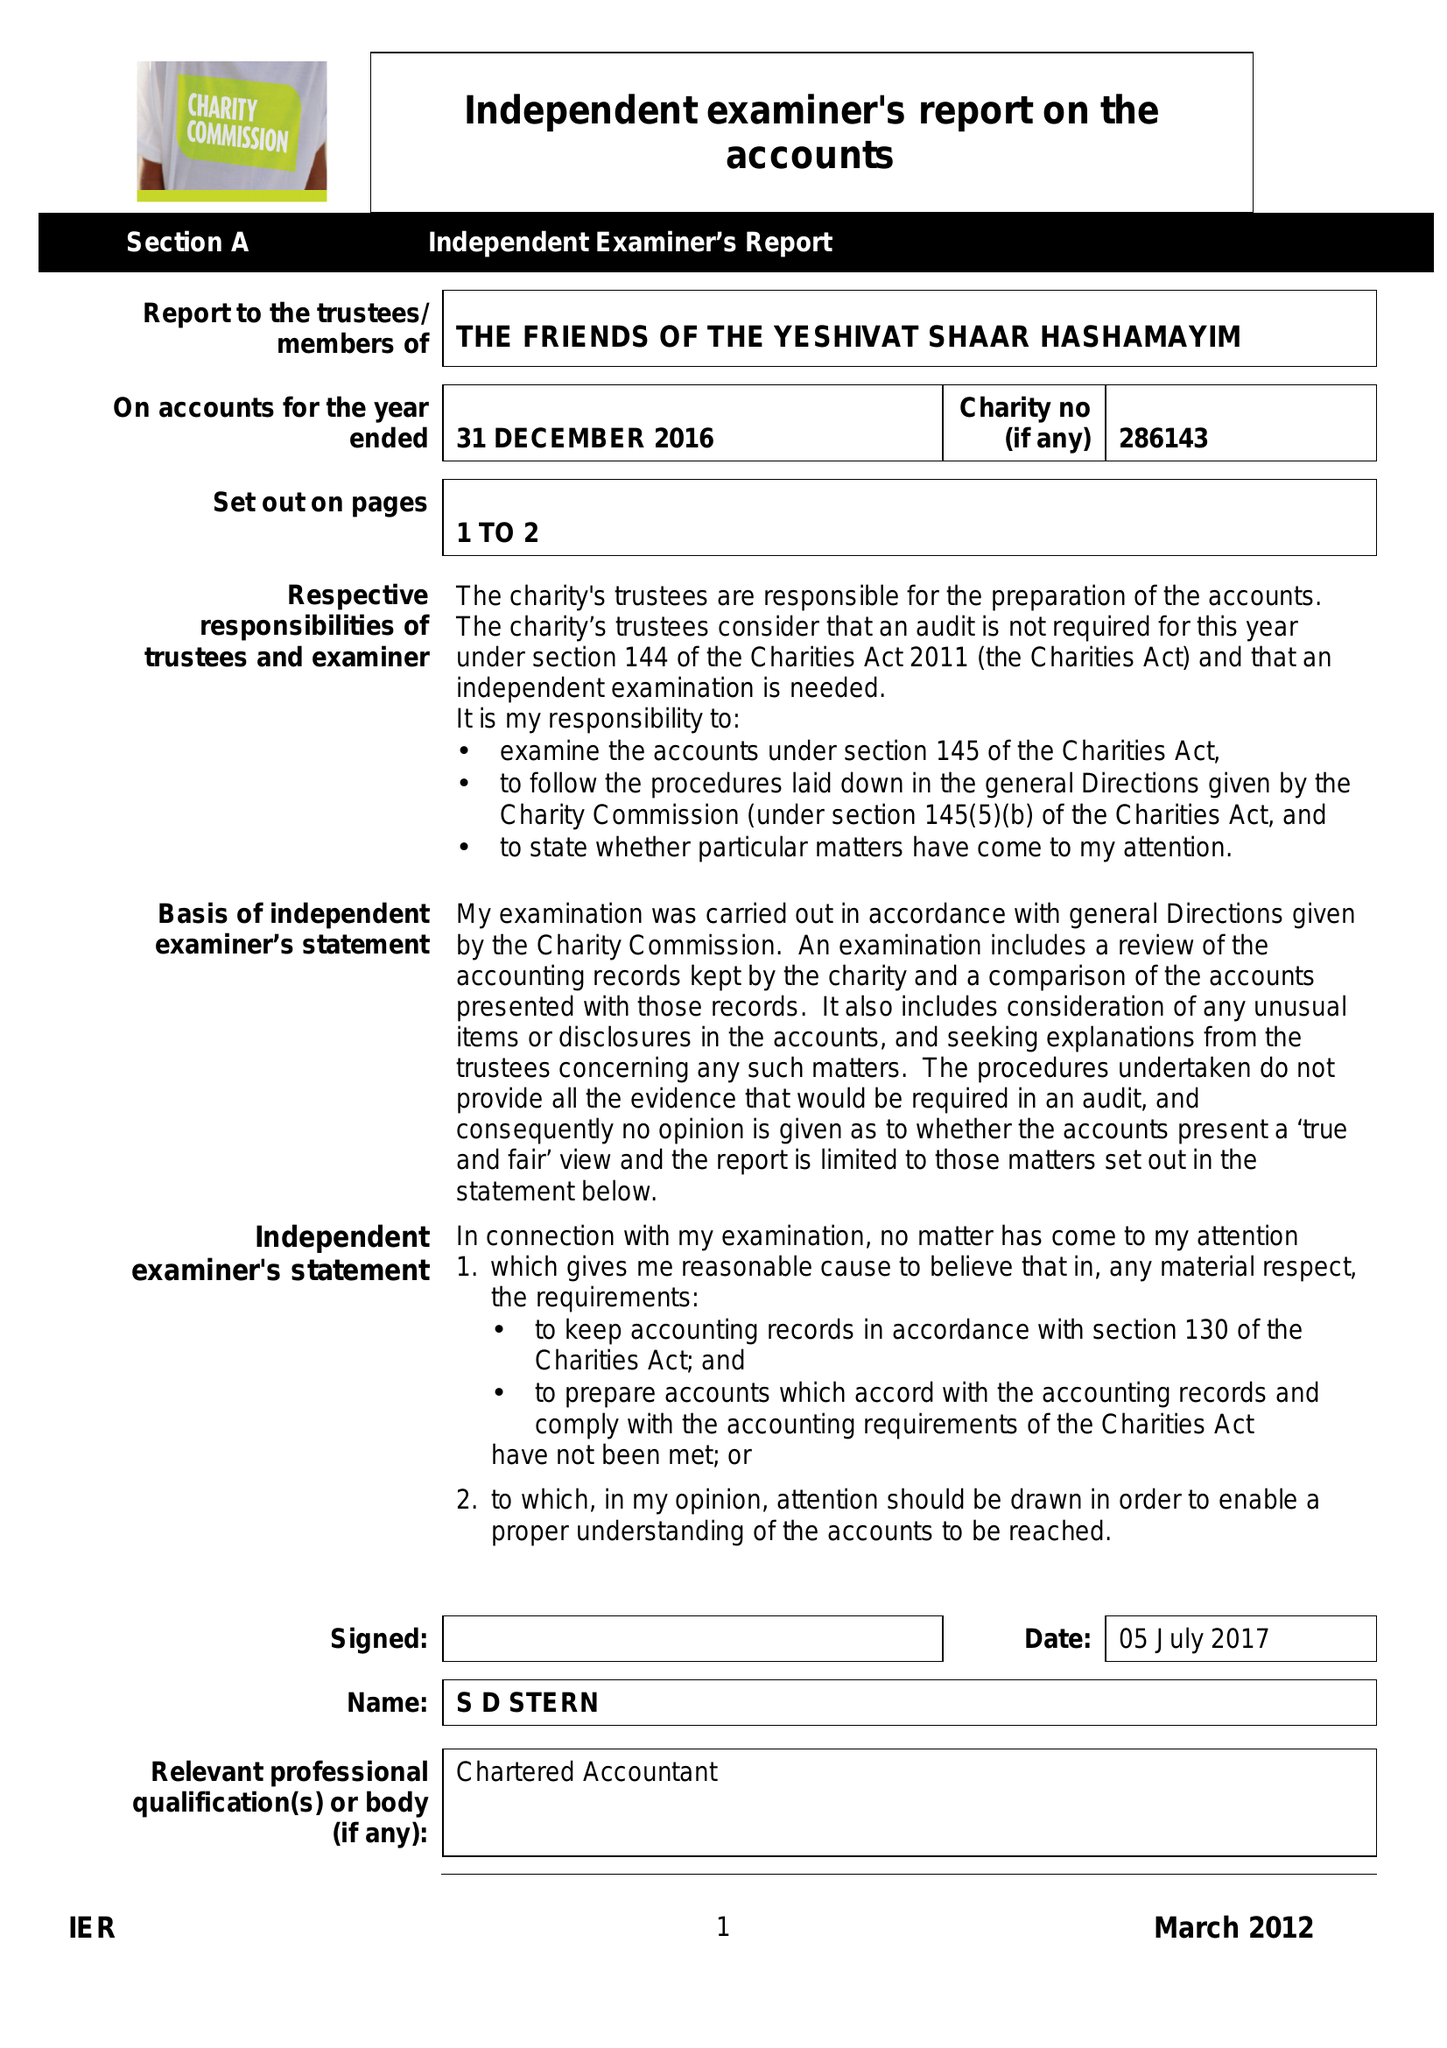What is the value for the charity_number?
Answer the question using a single word or phrase. 286143 